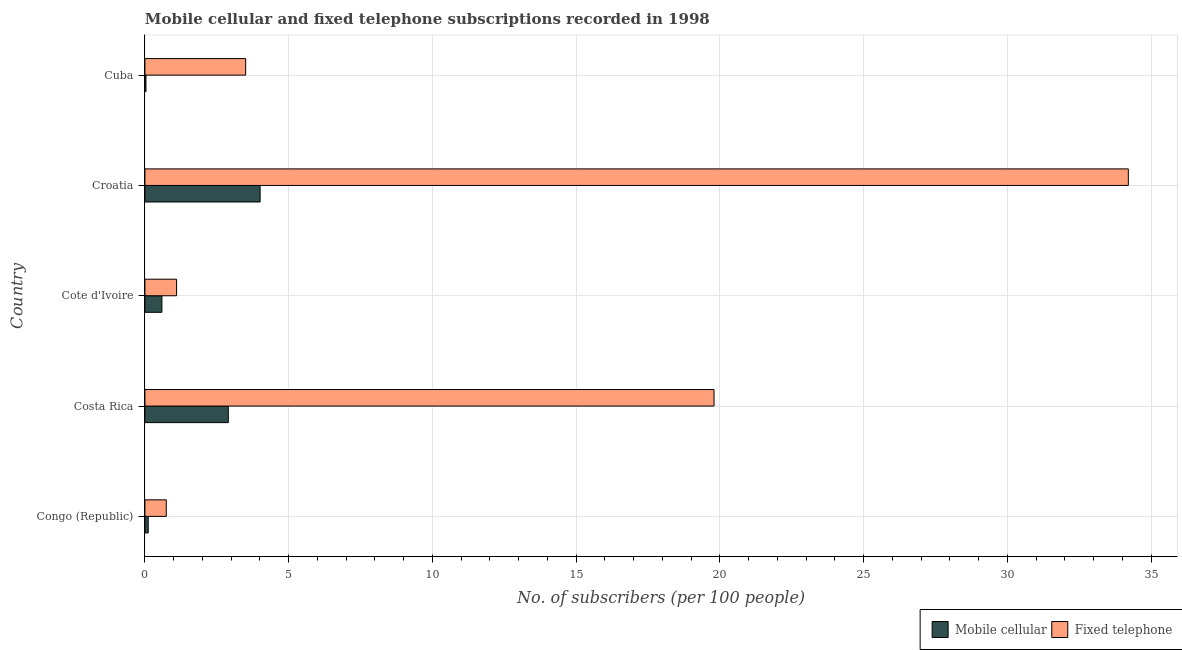How many groups of bars are there?
Offer a terse response. 5. Are the number of bars on each tick of the Y-axis equal?
Give a very brief answer. Yes. What is the label of the 4th group of bars from the top?
Your response must be concise. Costa Rica. In how many cases, is the number of bars for a given country not equal to the number of legend labels?
Make the answer very short. 0. What is the number of mobile cellular subscribers in Costa Rica?
Offer a very short reply. 2.9. Across all countries, what is the maximum number of fixed telephone subscribers?
Offer a terse response. 34.2. Across all countries, what is the minimum number of fixed telephone subscribers?
Your answer should be very brief. 0.74. In which country was the number of fixed telephone subscribers maximum?
Give a very brief answer. Croatia. In which country was the number of mobile cellular subscribers minimum?
Your response must be concise. Cuba. What is the total number of mobile cellular subscribers in the graph?
Make the answer very short. 7.65. What is the difference between the number of fixed telephone subscribers in Croatia and that in Cuba?
Your answer should be compact. 30.7. What is the difference between the number of fixed telephone subscribers in Cote d'Ivoire and the number of mobile cellular subscribers in Cuba?
Your answer should be very brief. 1.06. What is the average number of fixed telephone subscribers per country?
Provide a short and direct response. 11.87. What is the difference between the number of mobile cellular subscribers and number of fixed telephone subscribers in Congo (Republic)?
Give a very brief answer. -0.63. In how many countries, is the number of fixed telephone subscribers greater than 4 ?
Provide a short and direct response. 2. What is the ratio of the number of fixed telephone subscribers in Cote d'Ivoire to that in Cuba?
Provide a short and direct response. 0.31. Is the difference between the number of mobile cellular subscribers in Croatia and Cuba greater than the difference between the number of fixed telephone subscribers in Croatia and Cuba?
Your answer should be very brief. No. What is the difference between the highest and the second highest number of fixed telephone subscribers?
Provide a short and direct response. 14.41. What is the difference between the highest and the lowest number of fixed telephone subscribers?
Make the answer very short. 33.46. Is the sum of the number of mobile cellular subscribers in Congo (Republic) and Costa Rica greater than the maximum number of fixed telephone subscribers across all countries?
Your answer should be compact. No. What does the 1st bar from the top in Congo (Republic) represents?
Provide a succinct answer. Fixed telephone. What does the 1st bar from the bottom in Cote d'Ivoire represents?
Provide a succinct answer. Mobile cellular. How many countries are there in the graph?
Make the answer very short. 5. Does the graph contain any zero values?
Your answer should be very brief. No. Does the graph contain grids?
Offer a terse response. Yes. Where does the legend appear in the graph?
Provide a succinct answer. Bottom right. How many legend labels are there?
Provide a succinct answer. 2. How are the legend labels stacked?
Provide a short and direct response. Horizontal. What is the title of the graph?
Ensure brevity in your answer.  Mobile cellular and fixed telephone subscriptions recorded in 1998. What is the label or title of the X-axis?
Give a very brief answer. No. of subscribers (per 100 people). What is the label or title of the Y-axis?
Keep it short and to the point. Country. What is the No. of subscribers (per 100 people) in Mobile cellular in Congo (Republic)?
Offer a very short reply. 0.11. What is the No. of subscribers (per 100 people) of Fixed telephone in Congo (Republic)?
Your answer should be very brief. 0.74. What is the No. of subscribers (per 100 people) in Mobile cellular in Costa Rica?
Your answer should be very brief. 2.9. What is the No. of subscribers (per 100 people) of Fixed telephone in Costa Rica?
Offer a terse response. 19.79. What is the No. of subscribers (per 100 people) of Mobile cellular in Cote d'Ivoire?
Give a very brief answer. 0.59. What is the No. of subscribers (per 100 people) in Fixed telephone in Cote d'Ivoire?
Your answer should be very brief. 1.1. What is the No. of subscribers (per 100 people) of Mobile cellular in Croatia?
Offer a terse response. 4.01. What is the No. of subscribers (per 100 people) of Fixed telephone in Croatia?
Keep it short and to the point. 34.2. What is the No. of subscribers (per 100 people) in Mobile cellular in Cuba?
Your response must be concise. 0.04. What is the No. of subscribers (per 100 people) in Fixed telephone in Cuba?
Keep it short and to the point. 3.5. Across all countries, what is the maximum No. of subscribers (per 100 people) in Mobile cellular?
Offer a very short reply. 4.01. Across all countries, what is the maximum No. of subscribers (per 100 people) of Fixed telephone?
Make the answer very short. 34.2. Across all countries, what is the minimum No. of subscribers (per 100 people) in Mobile cellular?
Your answer should be compact. 0.04. Across all countries, what is the minimum No. of subscribers (per 100 people) of Fixed telephone?
Make the answer very short. 0.74. What is the total No. of subscribers (per 100 people) of Mobile cellular in the graph?
Make the answer very short. 7.65. What is the total No. of subscribers (per 100 people) in Fixed telephone in the graph?
Your answer should be very brief. 59.35. What is the difference between the No. of subscribers (per 100 people) in Mobile cellular in Congo (Republic) and that in Costa Rica?
Provide a short and direct response. -2.79. What is the difference between the No. of subscribers (per 100 people) of Fixed telephone in Congo (Republic) and that in Costa Rica?
Provide a short and direct response. -19.05. What is the difference between the No. of subscribers (per 100 people) in Mobile cellular in Congo (Republic) and that in Cote d'Ivoire?
Your response must be concise. -0.48. What is the difference between the No. of subscribers (per 100 people) of Fixed telephone in Congo (Republic) and that in Cote d'Ivoire?
Your answer should be compact. -0.36. What is the difference between the No. of subscribers (per 100 people) in Mobile cellular in Congo (Republic) and that in Croatia?
Offer a very short reply. -3.89. What is the difference between the No. of subscribers (per 100 people) of Fixed telephone in Congo (Republic) and that in Croatia?
Your answer should be compact. -33.46. What is the difference between the No. of subscribers (per 100 people) of Mobile cellular in Congo (Republic) and that in Cuba?
Give a very brief answer. 0.08. What is the difference between the No. of subscribers (per 100 people) in Fixed telephone in Congo (Republic) and that in Cuba?
Provide a short and direct response. -2.76. What is the difference between the No. of subscribers (per 100 people) of Mobile cellular in Costa Rica and that in Cote d'Ivoire?
Keep it short and to the point. 2.31. What is the difference between the No. of subscribers (per 100 people) in Fixed telephone in Costa Rica and that in Cote d'Ivoire?
Give a very brief answer. 18.69. What is the difference between the No. of subscribers (per 100 people) of Mobile cellular in Costa Rica and that in Croatia?
Your response must be concise. -1.11. What is the difference between the No. of subscribers (per 100 people) of Fixed telephone in Costa Rica and that in Croatia?
Your answer should be very brief. -14.41. What is the difference between the No. of subscribers (per 100 people) of Mobile cellular in Costa Rica and that in Cuba?
Provide a succinct answer. 2.86. What is the difference between the No. of subscribers (per 100 people) in Fixed telephone in Costa Rica and that in Cuba?
Make the answer very short. 16.29. What is the difference between the No. of subscribers (per 100 people) in Mobile cellular in Cote d'Ivoire and that in Croatia?
Your response must be concise. -3.42. What is the difference between the No. of subscribers (per 100 people) in Fixed telephone in Cote d'Ivoire and that in Croatia?
Make the answer very short. -33.1. What is the difference between the No. of subscribers (per 100 people) of Mobile cellular in Cote d'Ivoire and that in Cuba?
Offer a terse response. 0.55. What is the difference between the No. of subscribers (per 100 people) in Fixed telephone in Cote d'Ivoire and that in Cuba?
Ensure brevity in your answer.  -2.4. What is the difference between the No. of subscribers (per 100 people) in Mobile cellular in Croatia and that in Cuba?
Make the answer very short. 3.97. What is the difference between the No. of subscribers (per 100 people) of Fixed telephone in Croatia and that in Cuba?
Your answer should be very brief. 30.7. What is the difference between the No. of subscribers (per 100 people) of Mobile cellular in Congo (Republic) and the No. of subscribers (per 100 people) of Fixed telephone in Costa Rica?
Offer a terse response. -19.68. What is the difference between the No. of subscribers (per 100 people) of Mobile cellular in Congo (Republic) and the No. of subscribers (per 100 people) of Fixed telephone in Cote d'Ivoire?
Your response must be concise. -0.99. What is the difference between the No. of subscribers (per 100 people) in Mobile cellular in Congo (Republic) and the No. of subscribers (per 100 people) in Fixed telephone in Croatia?
Keep it short and to the point. -34.09. What is the difference between the No. of subscribers (per 100 people) of Mobile cellular in Congo (Republic) and the No. of subscribers (per 100 people) of Fixed telephone in Cuba?
Offer a terse response. -3.39. What is the difference between the No. of subscribers (per 100 people) in Mobile cellular in Costa Rica and the No. of subscribers (per 100 people) in Fixed telephone in Cote d'Ivoire?
Provide a succinct answer. 1.8. What is the difference between the No. of subscribers (per 100 people) of Mobile cellular in Costa Rica and the No. of subscribers (per 100 people) of Fixed telephone in Croatia?
Provide a short and direct response. -31.3. What is the difference between the No. of subscribers (per 100 people) of Mobile cellular in Costa Rica and the No. of subscribers (per 100 people) of Fixed telephone in Cuba?
Keep it short and to the point. -0.6. What is the difference between the No. of subscribers (per 100 people) of Mobile cellular in Cote d'Ivoire and the No. of subscribers (per 100 people) of Fixed telephone in Croatia?
Offer a very short reply. -33.61. What is the difference between the No. of subscribers (per 100 people) of Mobile cellular in Cote d'Ivoire and the No. of subscribers (per 100 people) of Fixed telephone in Cuba?
Give a very brief answer. -2.91. What is the difference between the No. of subscribers (per 100 people) of Mobile cellular in Croatia and the No. of subscribers (per 100 people) of Fixed telephone in Cuba?
Provide a succinct answer. 0.5. What is the average No. of subscribers (per 100 people) of Mobile cellular per country?
Your answer should be very brief. 1.53. What is the average No. of subscribers (per 100 people) in Fixed telephone per country?
Keep it short and to the point. 11.87. What is the difference between the No. of subscribers (per 100 people) in Mobile cellular and No. of subscribers (per 100 people) in Fixed telephone in Congo (Republic)?
Your response must be concise. -0.63. What is the difference between the No. of subscribers (per 100 people) in Mobile cellular and No. of subscribers (per 100 people) in Fixed telephone in Costa Rica?
Give a very brief answer. -16.89. What is the difference between the No. of subscribers (per 100 people) in Mobile cellular and No. of subscribers (per 100 people) in Fixed telephone in Cote d'Ivoire?
Your answer should be compact. -0.51. What is the difference between the No. of subscribers (per 100 people) of Mobile cellular and No. of subscribers (per 100 people) of Fixed telephone in Croatia?
Give a very brief answer. -30.2. What is the difference between the No. of subscribers (per 100 people) of Mobile cellular and No. of subscribers (per 100 people) of Fixed telephone in Cuba?
Keep it short and to the point. -3.47. What is the ratio of the No. of subscribers (per 100 people) in Mobile cellular in Congo (Republic) to that in Costa Rica?
Your answer should be compact. 0.04. What is the ratio of the No. of subscribers (per 100 people) in Fixed telephone in Congo (Republic) to that in Costa Rica?
Provide a short and direct response. 0.04. What is the ratio of the No. of subscribers (per 100 people) in Mobile cellular in Congo (Republic) to that in Cote d'Ivoire?
Your response must be concise. 0.19. What is the ratio of the No. of subscribers (per 100 people) of Fixed telephone in Congo (Republic) to that in Cote d'Ivoire?
Your response must be concise. 0.67. What is the ratio of the No. of subscribers (per 100 people) in Mobile cellular in Congo (Republic) to that in Croatia?
Provide a short and direct response. 0.03. What is the ratio of the No. of subscribers (per 100 people) in Fixed telephone in Congo (Republic) to that in Croatia?
Make the answer very short. 0.02. What is the ratio of the No. of subscribers (per 100 people) of Mobile cellular in Congo (Republic) to that in Cuba?
Keep it short and to the point. 3.12. What is the ratio of the No. of subscribers (per 100 people) in Fixed telephone in Congo (Republic) to that in Cuba?
Keep it short and to the point. 0.21. What is the ratio of the No. of subscribers (per 100 people) in Mobile cellular in Costa Rica to that in Cote d'Ivoire?
Your answer should be compact. 4.91. What is the ratio of the No. of subscribers (per 100 people) in Fixed telephone in Costa Rica to that in Cote d'Ivoire?
Keep it short and to the point. 17.97. What is the ratio of the No. of subscribers (per 100 people) of Mobile cellular in Costa Rica to that in Croatia?
Keep it short and to the point. 0.72. What is the ratio of the No. of subscribers (per 100 people) in Fixed telephone in Costa Rica to that in Croatia?
Offer a terse response. 0.58. What is the ratio of the No. of subscribers (per 100 people) in Mobile cellular in Costa Rica to that in Cuba?
Your answer should be compact. 79.11. What is the ratio of the No. of subscribers (per 100 people) in Fixed telephone in Costa Rica to that in Cuba?
Ensure brevity in your answer.  5.65. What is the ratio of the No. of subscribers (per 100 people) in Mobile cellular in Cote d'Ivoire to that in Croatia?
Make the answer very short. 0.15. What is the ratio of the No. of subscribers (per 100 people) in Fixed telephone in Cote d'Ivoire to that in Croatia?
Provide a short and direct response. 0.03. What is the ratio of the No. of subscribers (per 100 people) in Mobile cellular in Cote d'Ivoire to that in Cuba?
Provide a short and direct response. 16.12. What is the ratio of the No. of subscribers (per 100 people) in Fixed telephone in Cote d'Ivoire to that in Cuba?
Your answer should be very brief. 0.31. What is the ratio of the No. of subscribers (per 100 people) in Mobile cellular in Croatia to that in Cuba?
Provide a succinct answer. 109.29. What is the ratio of the No. of subscribers (per 100 people) of Fixed telephone in Croatia to that in Cuba?
Keep it short and to the point. 9.76. What is the difference between the highest and the second highest No. of subscribers (per 100 people) of Mobile cellular?
Give a very brief answer. 1.11. What is the difference between the highest and the second highest No. of subscribers (per 100 people) of Fixed telephone?
Offer a very short reply. 14.41. What is the difference between the highest and the lowest No. of subscribers (per 100 people) in Mobile cellular?
Ensure brevity in your answer.  3.97. What is the difference between the highest and the lowest No. of subscribers (per 100 people) of Fixed telephone?
Give a very brief answer. 33.46. 